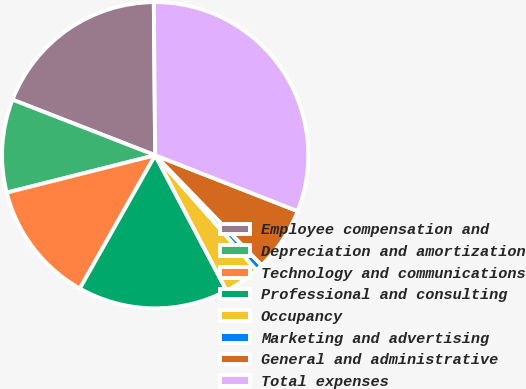Convert chart. <chart><loc_0><loc_0><loc_500><loc_500><pie_chart><fcel>Employee compensation and<fcel>Depreciation and amortization<fcel>Technology and communications<fcel>Professional and consulting<fcel>Occupancy<fcel>Marketing and advertising<fcel>General and administrative<fcel>Total expenses<nl><fcel>18.95%<fcel>9.84%<fcel>12.88%<fcel>15.92%<fcel>3.77%<fcel>0.74%<fcel>6.81%<fcel>31.09%<nl></chart> 